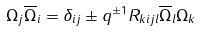<formula> <loc_0><loc_0><loc_500><loc_500>\Omega _ { j } \overline { \Omega } _ { i } = \delta _ { i j } \pm q ^ { \pm 1 } R _ { k i j l } \overline { \Omega } _ { l } \Omega _ { k }</formula> 